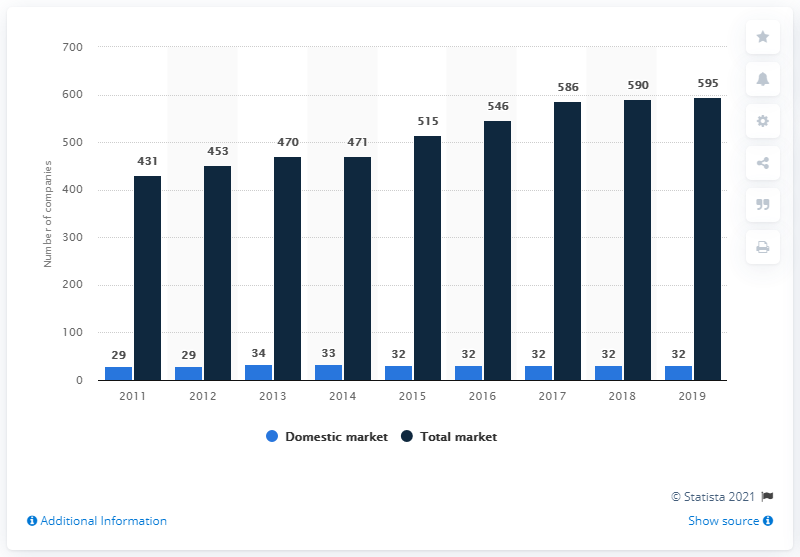Give some essential details in this illustration. In 2019, there were a total of 595 companies operating in the insurance sector in Cyprus. There were 32 companies operating in the insurance sector in Cyprus in 2019. 